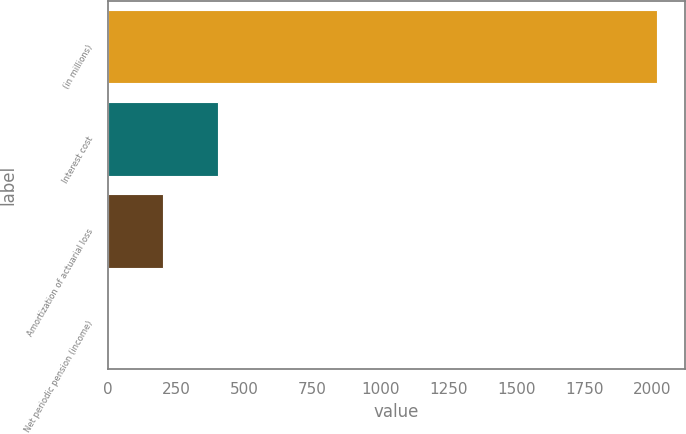Convert chart. <chart><loc_0><loc_0><loc_500><loc_500><bar_chart><fcel>(in millions)<fcel>Interest cost<fcel>Amortization of actuarial loss<fcel>Net periodic pension (income)<nl><fcel>2017<fcel>405<fcel>203.5<fcel>2<nl></chart> 